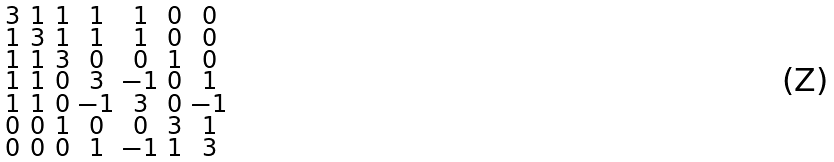<formula> <loc_0><loc_0><loc_500><loc_500>\begin{smallmatrix} 3 & 1 & 1 & 1 & 1 & 0 & 0 \\ 1 & 3 & 1 & 1 & 1 & 0 & 0 \\ 1 & 1 & 3 & 0 & 0 & 1 & 0 \\ 1 & 1 & 0 & 3 & - 1 & 0 & 1 \\ 1 & 1 & 0 & - 1 & 3 & 0 & - 1 \\ 0 & 0 & 1 & 0 & 0 & 3 & 1 \\ 0 & 0 & 0 & 1 & - 1 & 1 & 3 \end{smallmatrix}</formula> 